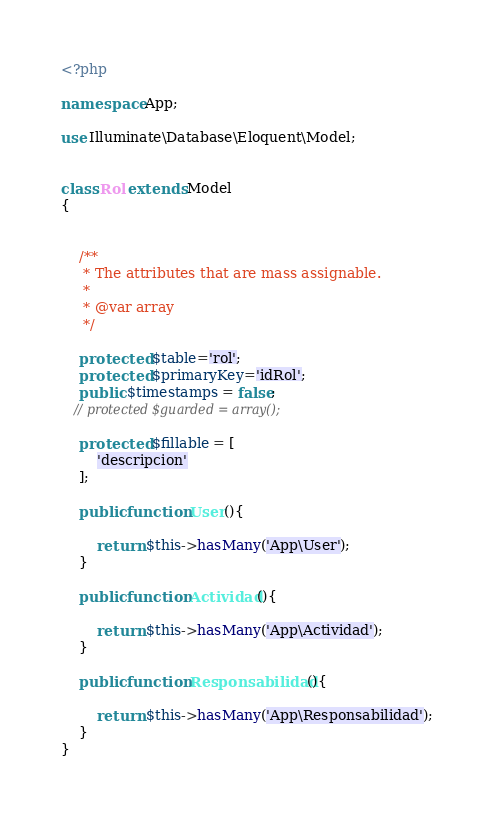Convert code to text. <code><loc_0><loc_0><loc_500><loc_500><_PHP_><?php

namespace App;

use Illuminate\Database\Eloquent\Model;


class Rol extends Model
{
   

    /**
     * The attributes that are mass assignable.
     *
     * @var array
     */

    protected $table='rol';
    protected $primaryKey='idRol';
    public $timestamps = false;
   // protected $guarded = array();

    protected $fillable = [
        'descripcion'
    ];
    
    public function User(){

        return $this->hasMany('App\User');
    }

    public function Actividad(){

        return $this->hasMany('App\Actividad');
    }

    public function Responsabilidad(){

        return $this->hasMany('App\Responsabilidad');
    }
}
</code> 